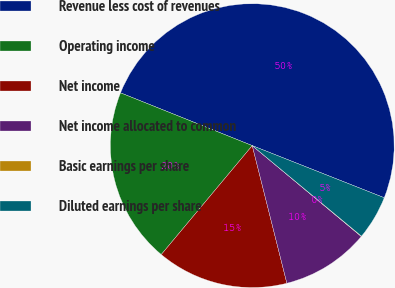Convert chart to OTSL. <chart><loc_0><loc_0><loc_500><loc_500><pie_chart><fcel>Revenue less cost of revenues<fcel>Operating income<fcel>Net income<fcel>Net income allocated to common<fcel>Basic earnings per share<fcel>Diluted earnings per share<nl><fcel>49.92%<fcel>19.99%<fcel>15.0%<fcel>10.02%<fcel>0.04%<fcel>5.03%<nl></chart> 